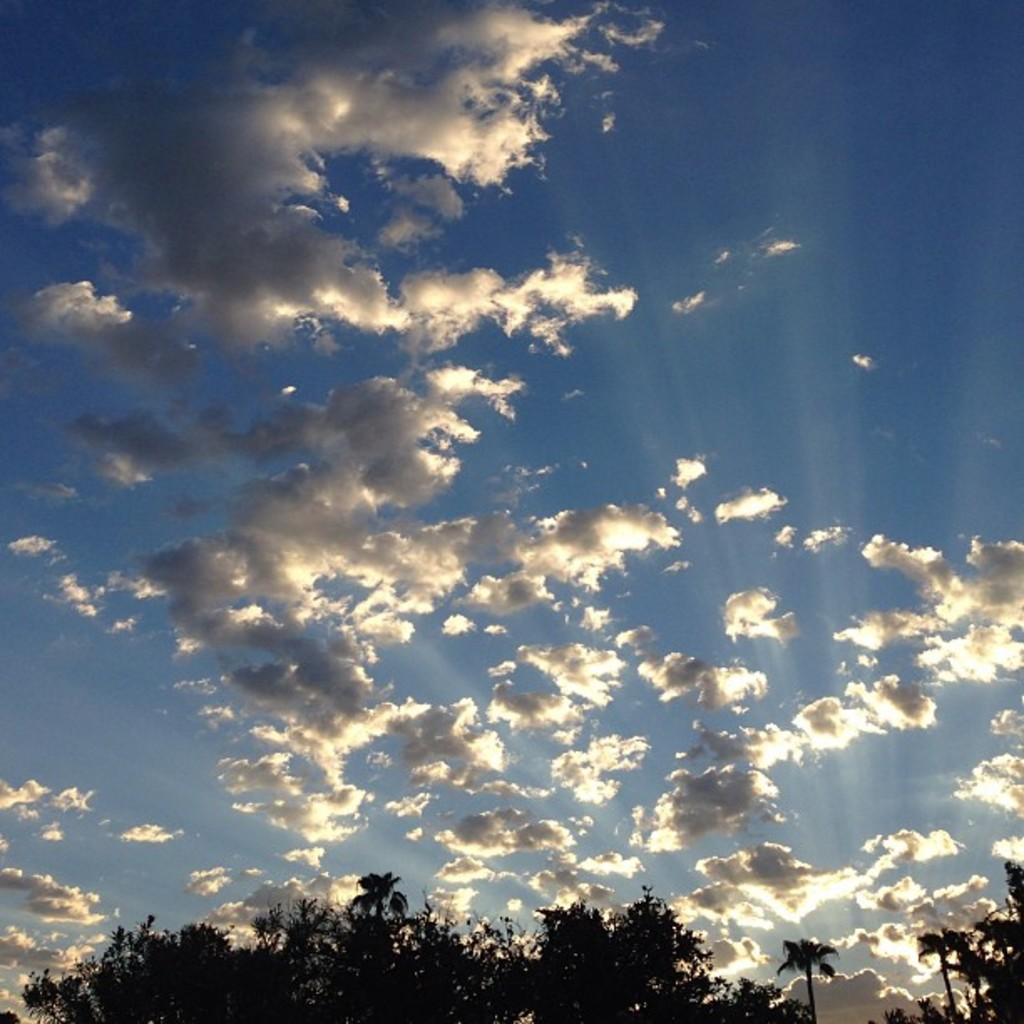What type of vegetation can be seen in the image? There are trees in the image. What is visible in the sky at the top of the image? There are clouds visible in the sky at the top of the image. What is the rate of the hospital's success in the image? There is no hospital or any indication of success rates in the image; it features trees and clouds. 